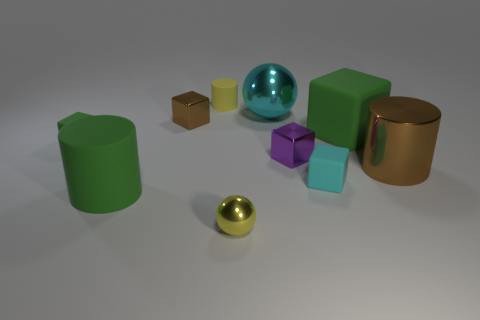Subtract all large green matte cubes. How many cubes are left? 4 Subtract all red blocks. Subtract all yellow balls. How many blocks are left? 5 Subtract all balls. How many objects are left? 8 Subtract 0 purple balls. How many objects are left? 10 Subtract all tiny green cubes. Subtract all brown shiny cubes. How many objects are left? 8 Add 8 brown metallic blocks. How many brown metallic blocks are left? 9 Add 4 red matte cylinders. How many red matte cylinders exist? 4 